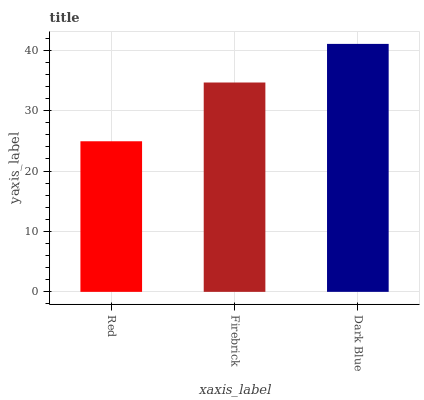Is Firebrick the minimum?
Answer yes or no. No. Is Firebrick the maximum?
Answer yes or no. No. Is Firebrick greater than Red?
Answer yes or no. Yes. Is Red less than Firebrick?
Answer yes or no. Yes. Is Red greater than Firebrick?
Answer yes or no. No. Is Firebrick less than Red?
Answer yes or no. No. Is Firebrick the high median?
Answer yes or no. Yes. Is Firebrick the low median?
Answer yes or no. Yes. Is Red the high median?
Answer yes or no. No. Is Red the low median?
Answer yes or no. No. 